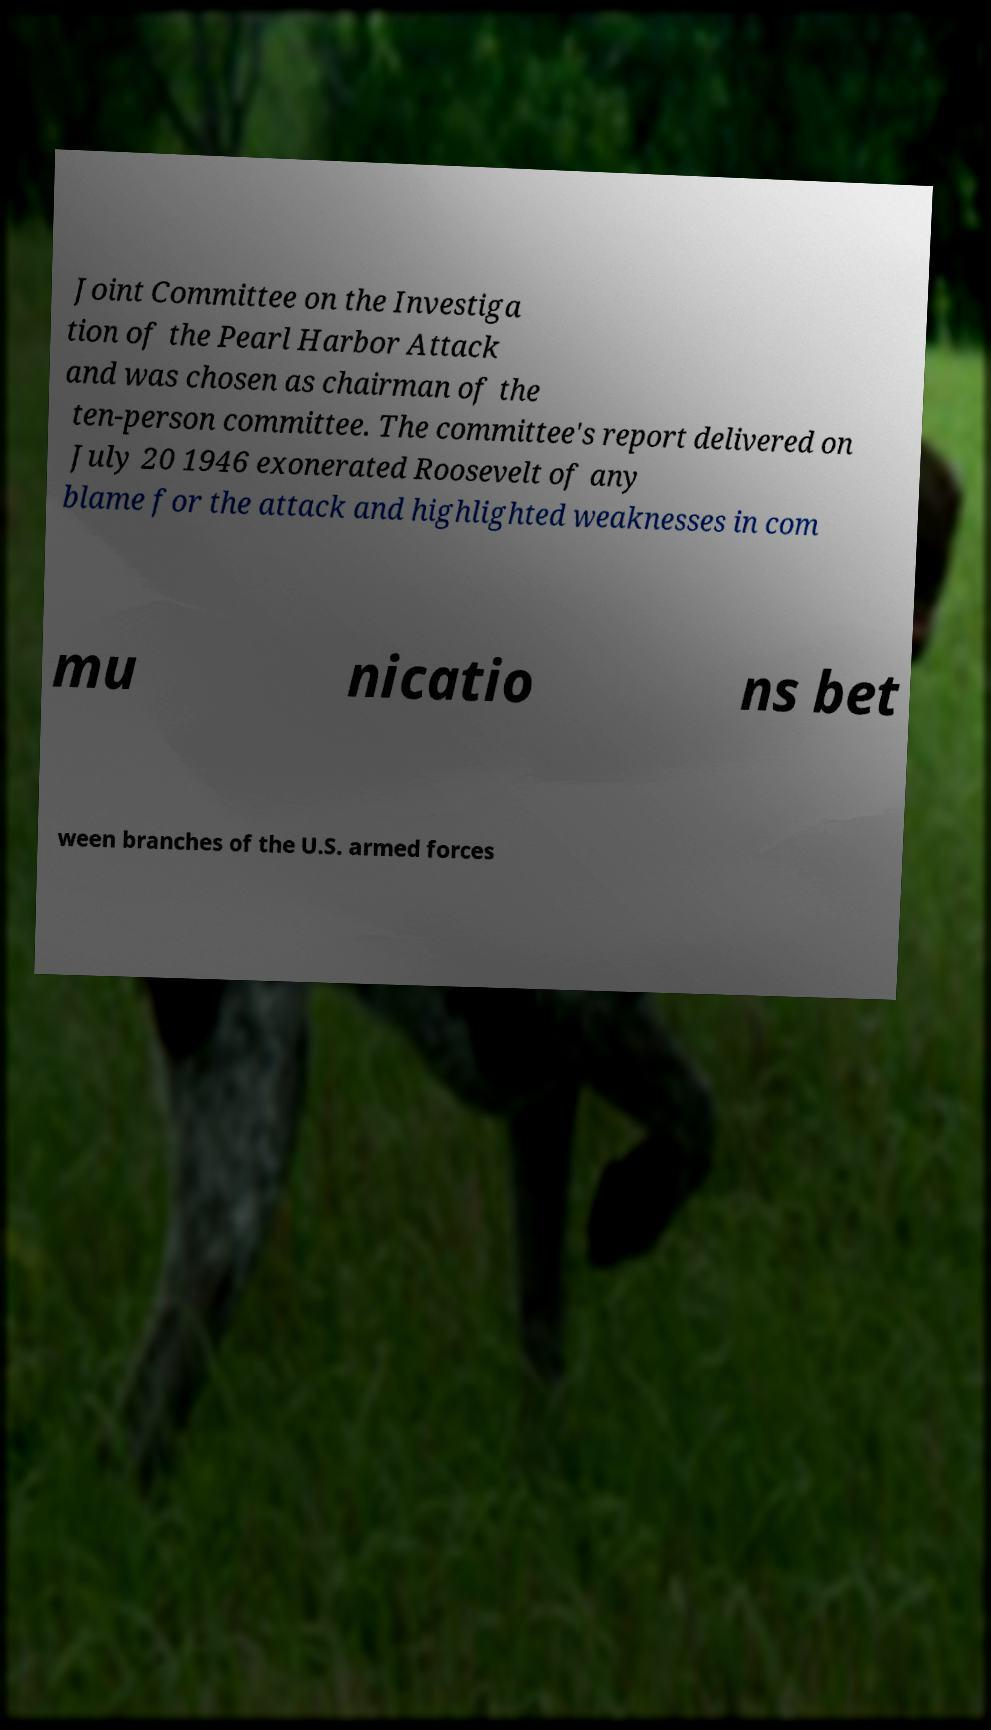Can you read and provide the text displayed in the image?This photo seems to have some interesting text. Can you extract and type it out for me? Joint Committee on the Investiga tion of the Pearl Harbor Attack and was chosen as chairman of the ten-person committee. The committee's report delivered on July 20 1946 exonerated Roosevelt of any blame for the attack and highlighted weaknesses in com mu nicatio ns bet ween branches of the U.S. armed forces 